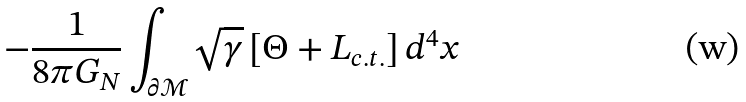Convert formula to latex. <formula><loc_0><loc_0><loc_500><loc_500>- \frac { 1 } { 8 \pi G _ { N } } \int _ { \partial \mathcal { M } } \sqrt { \gamma } \left [ \Theta + L _ { c . t . } \right ] d ^ { 4 } x</formula> 